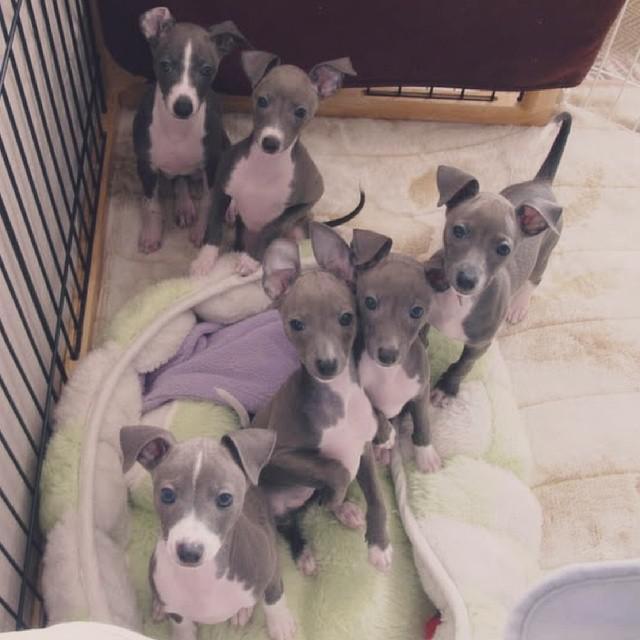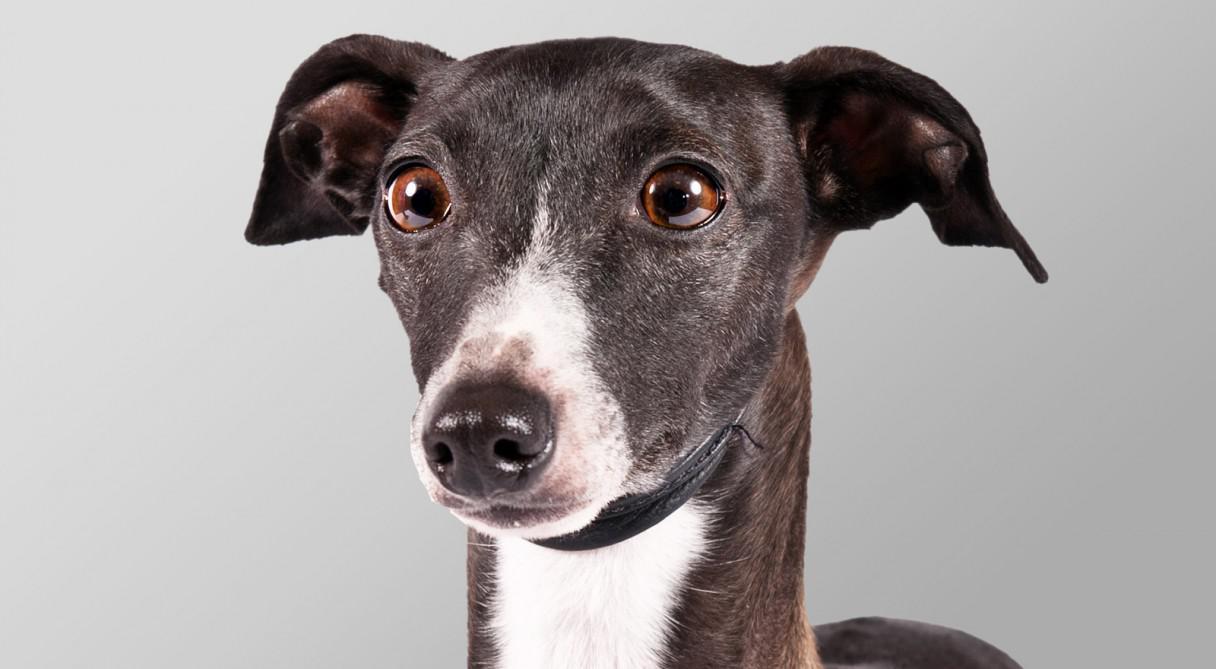The first image is the image on the left, the second image is the image on the right. Given the left and right images, does the statement "the dog in the image on the right is standing on all fours" hold true? Answer yes or no. No. The first image is the image on the left, the second image is the image on the right. For the images displayed, is the sentence "All images show one dog, with the dog on the right standing indoors." factually correct? Answer yes or no. No. 